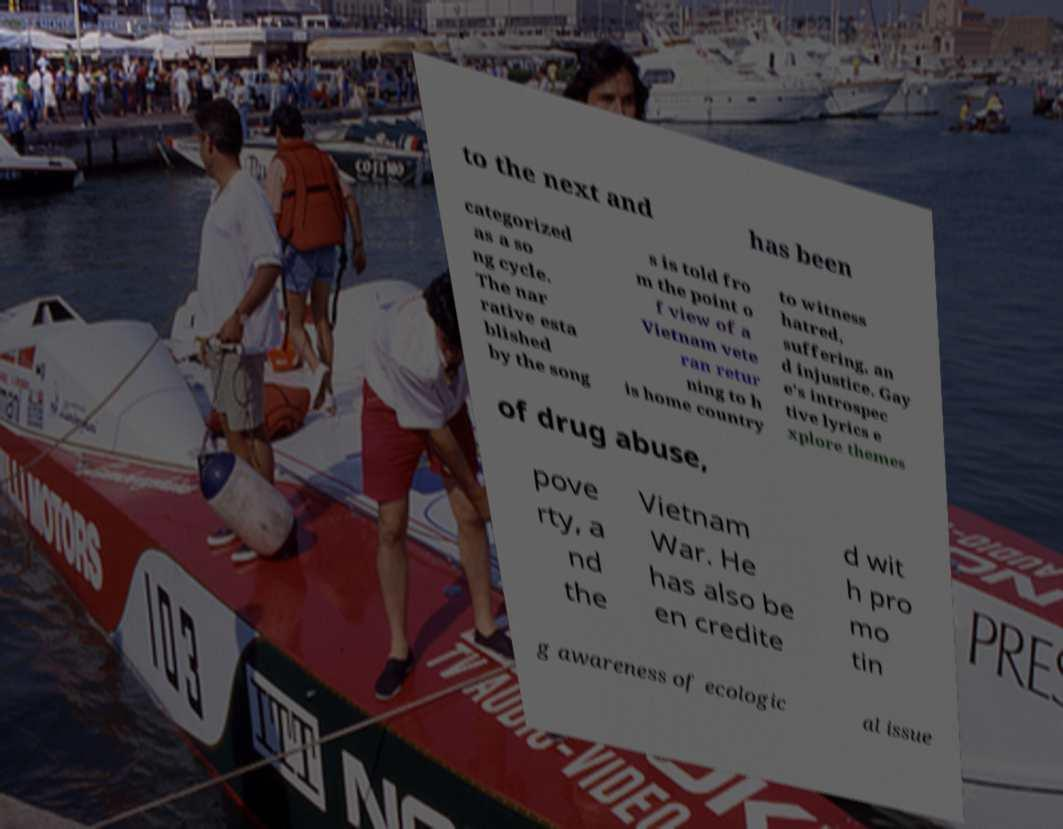Please read and relay the text visible in this image. What does it say? to the next and has been categorized as a so ng cycle. The nar rative esta blished by the song s is told fro m the point o f view of a Vietnam vete ran retur ning to h is home country to witness hatred, suffering, an d injustice. Gay e's introspec tive lyrics e xplore themes of drug abuse, pove rty, a nd the Vietnam War. He has also be en credite d wit h pro mo tin g awareness of ecologic al issue 